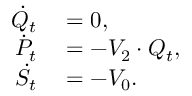<formula> <loc_0><loc_0><loc_500><loc_500>\begin{array} { r l } { \dot { Q } _ { t } } & = 0 , } \\ { \dot { P } _ { t } } & = - V _ { 2 } \cdot Q _ { t } , } \\ { \dot { S } _ { t } } & = - V _ { 0 } . } \end{array}</formula> 